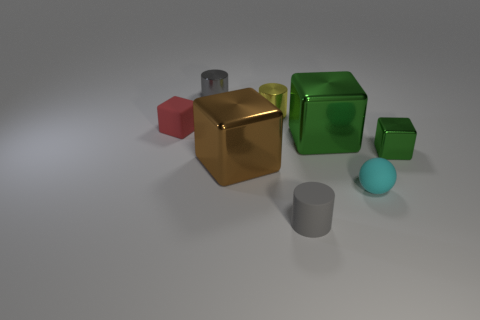There is a cube that is to the right of the large green shiny cube; are there any green things in front of it?
Provide a succinct answer. No. How big is the matte cube?
Your answer should be compact. Small. How many things are either big red metallic balls or small red objects?
Make the answer very short. 1. Does the tiny gray cylinder in front of the big green metallic thing have the same material as the tiny cube that is to the right of the gray metallic object?
Offer a very short reply. No. What is the color of the tiny cylinder that is made of the same material as the tiny yellow object?
Your answer should be very brief. Gray. What number of cyan balls are the same size as the brown object?
Your answer should be very brief. 0. How many other objects are there of the same color as the small matte block?
Offer a very short reply. 0. There is a small matte thing on the left side of the big brown object; is it the same shape as the matte thing that is on the right side of the big green metal thing?
Give a very brief answer. No. There is a cyan object that is the same size as the gray rubber cylinder; what shape is it?
Give a very brief answer. Sphere. Is the number of spheres on the right side of the small matte sphere the same as the number of tiny cyan objects to the left of the small yellow metallic cylinder?
Ensure brevity in your answer.  Yes. 